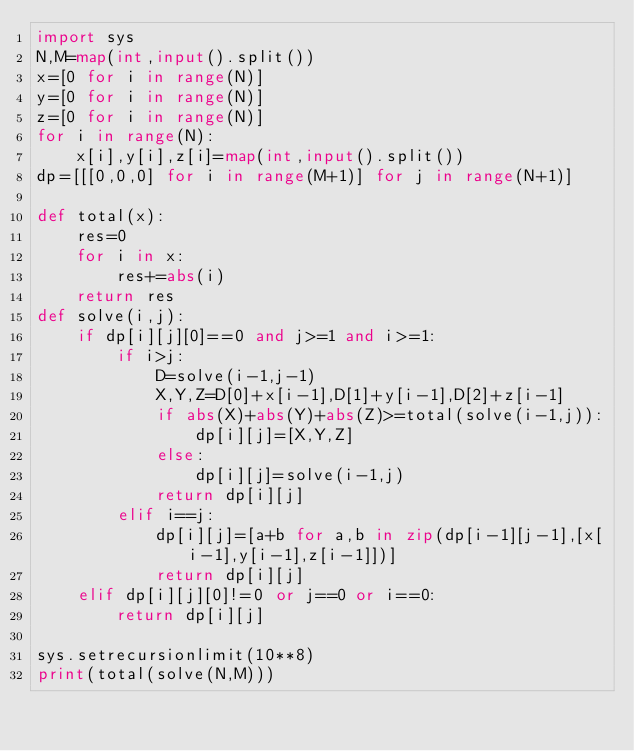Convert code to text. <code><loc_0><loc_0><loc_500><loc_500><_Python_>import sys
N,M=map(int,input().split())
x=[0 for i in range(N)]
y=[0 for i in range(N)]
z=[0 for i in range(N)]
for i in range(N):
    x[i],y[i],z[i]=map(int,input().split())
dp=[[[0,0,0] for i in range(M+1)] for j in range(N+1)]

def total(x):
    res=0
    for i in x:
        res+=abs(i)
    return res
def solve(i,j):
    if dp[i][j][0]==0 and j>=1 and i>=1:
        if i>j:
            D=solve(i-1,j-1)
            X,Y,Z=D[0]+x[i-1],D[1]+y[i-1],D[2]+z[i-1]
            if abs(X)+abs(Y)+abs(Z)>=total(solve(i-1,j)):
                dp[i][j]=[X,Y,Z]
            else:
                dp[i][j]=solve(i-1,j)
            return dp[i][j]
        elif i==j:
            dp[i][j]=[a+b for a,b in zip(dp[i-1][j-1],[x[i-1],y[i-1],z[i-1]])]
            return dp[i][j]
    elif dp[i][j][0]!=0 or j==0 or i==0:
        return dp[i][j]

sys.setrecursionlimit(10**8)
print(total(solve(N,M)))

</code> 